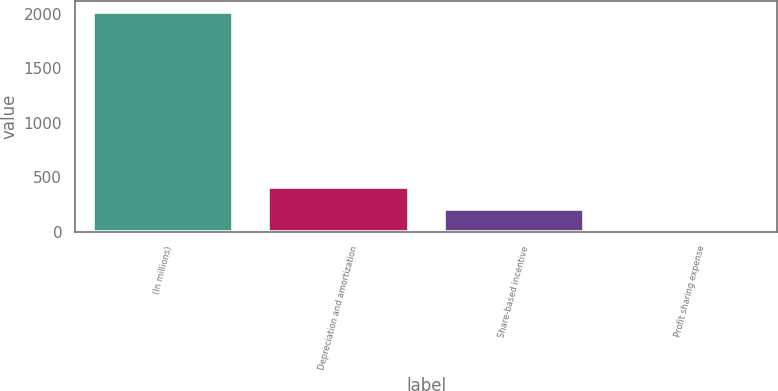<chart> <loc_0><loc_0><loc_500><loc_500><bar_chart><fcel>(In millions)<fcel>Depreciation and amortization<fcel>Share-based incentive<fcel>Profit sharing expense<nl><fcel>2017<fcel>405.8<fcel>204.4<fcel>3<nl></chart> 